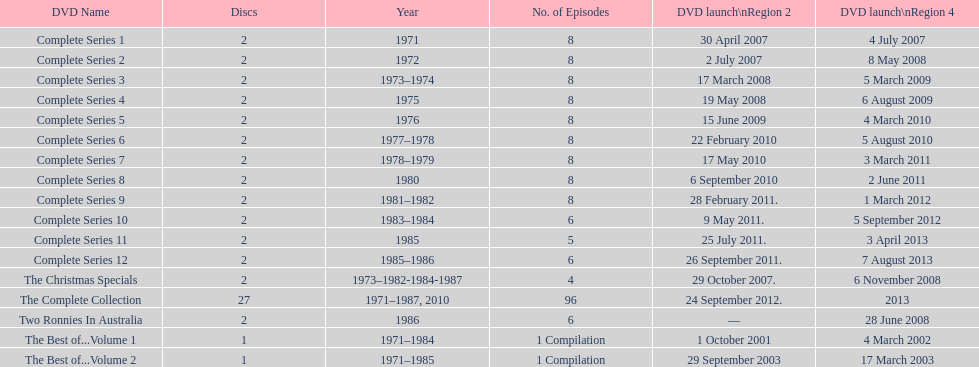What is the total of all dics listed in the table? 57. 